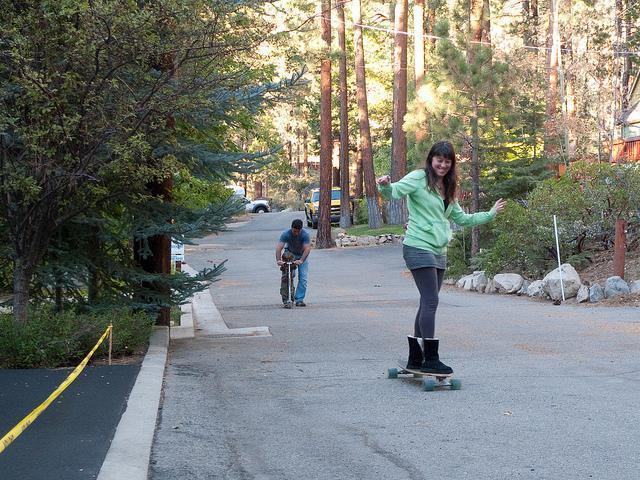How many people are shown?
Give a very brief answer. 2. How many bikes can you spot?
Give a very brief answer. 0. 